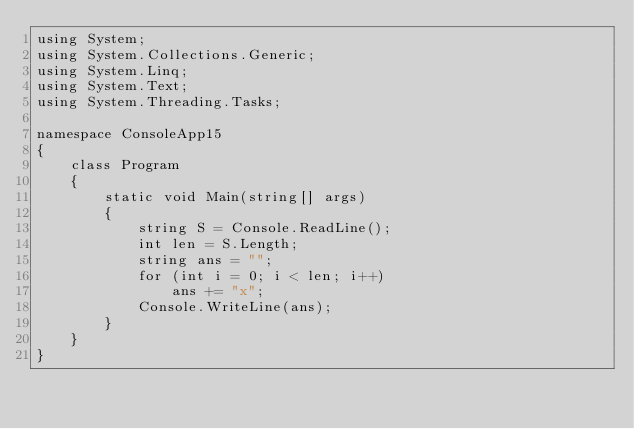Convert code to text. <code><loc_0><loc_0><loc_500><loc_500><_C#_>using System;
using System.Collections.Generic;
using System.Linq;
using System.Text;
using System.Threading.Tasks;

namespace ConsoleApp15
{
    class Program
    {
        static void Main(string[] args)
        {
            string S = Console.ReadLine();
            int len = S.Length;
            string ans = "";
            for (int i = 0; i < len; i++)
                ans += "x";
            Console.WriteLine(ans);
        }
    }
}
</code> 